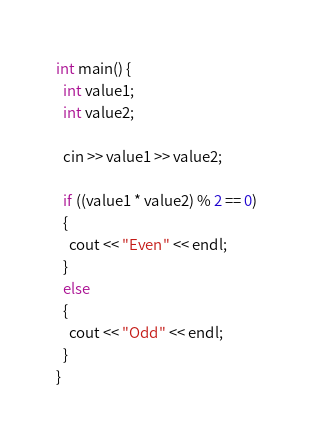<code> <loc_0><loc_0><loc_500><loc_500><_C++_>int main() {
  int value1;
  int value2;
  
  cin >> value1 >> value2;
  
  if ((value1 * value2) % 2 == 0)
  {
    cout << "Even" << endl;
  }
  else
  {
    cout << "Odd" << endl;
  }
}

</code> 